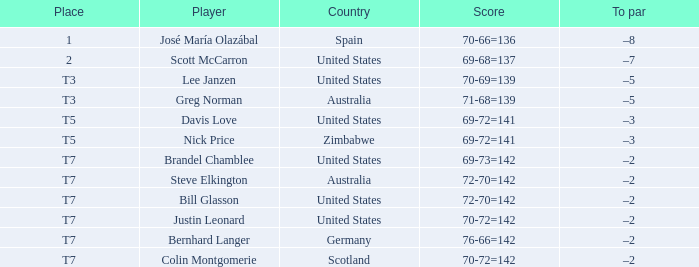Write the full table. {'header': ['Place', 'Player', 'Country', 'Score', 'To par'], 'rows': [['1', 'José María Olazábal', 'Spain', '70-66=136', '–8'], ['2', 'Scott McCarron', 'United States', '69-68=137', '–7'], ['T3', 'Lee Janzen', 'United States', '70-69=139', '–5'], ['T3', 'Greg Norman', 'Australia', '71-68=139', '–5'], ['T5', 'Davis Love', 'United States', '69-72=141', '–3'], ['T5', 'Nick Price', 'Zimbabwe', '69-72=141', '–3'], ['T7', 'Brandel Chamblee', 'United States', '69-73=142', '–2'], ['T7', 'Steve Elkington', 'Australia', '72-70=142', '–2'], ['T7', 'Bill Glasson', 'United States', '72-70=142', '–2'], ['T7', 'Justin Leonard', 'United States', '70-72=142', '–2'], ['T7', 'Bernhard Langer', 'Germany', '76-66=142', '–2'], ['T7', 'Colin Montgomerie', 'Scotland', '70-72=142', '–2']]} Which player scored 70-72=142? (question 3) Justin Leonard, Colin Montgomerie. 